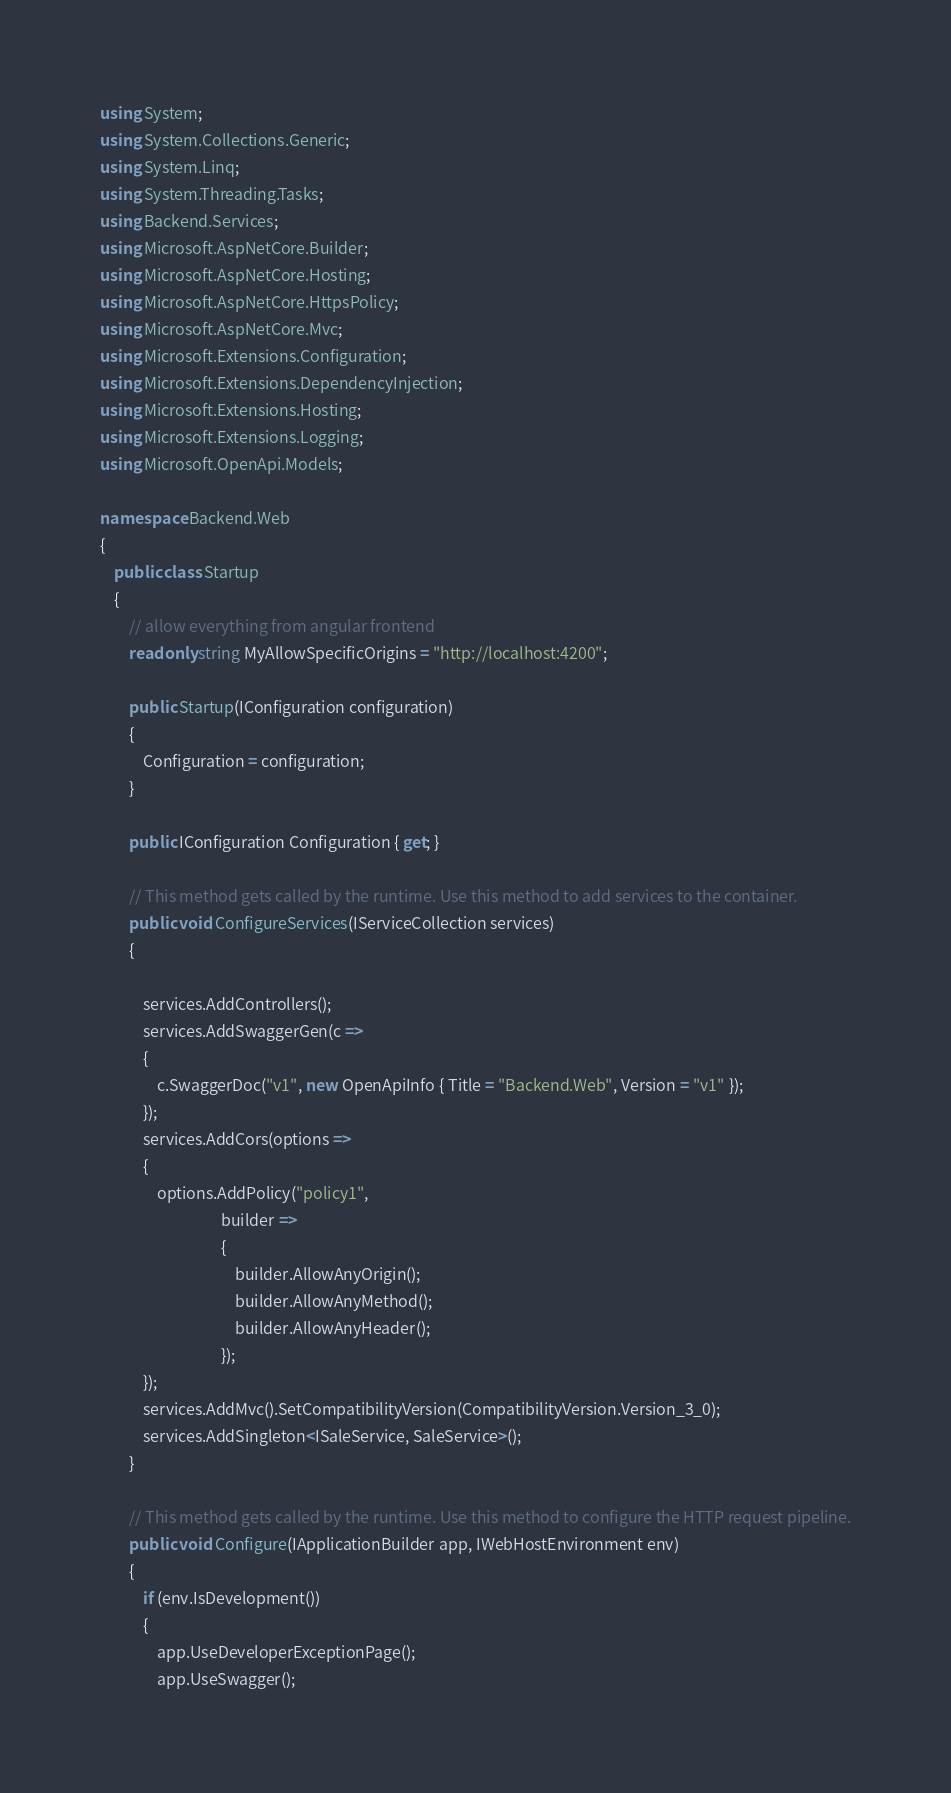<code> <loc_0><loc_0><loc_500><loc_500><_C#_>using System;
using System.Collections.Generic;
using System.Linq;
using System.Threading.Tasks;
using Backend.Services;
using Microsoft.AspNetCore.Builder;
using Microsoft.AspNetCore.Hosting;
using Microsoft.AspNetCore.HttpsPolicy;
using Microsoft.AspNetCore.Mvc;
using Microsoft.Extensions.Configuration;
using Microsoft.Extensions.DependencyInjection;
using Microsoft.Extensions.Hosting;
using Microsoft.Extensions.Logging;
using Microsoft.OpenApi.Models;

namespace Backend.Web
{
    public class Startup
    {
        // allow everything from angular frontend
        readonly string MyAllowSpecificOrigins = "http://localhost:4200";

        public Startup(IConfiguration configuration)
        {
            Configuration = configuration;
        }

        public IConfiguration Configuration { get; }

        // This method gets called by the runtime. Use this method to add services to the container.
        public void ConfigureServices(IServiceCollection services)
        {

            services.AddControllers();
            services.AddSwaggerGen(c =>
            {
                c.SwaggerDoc("v1", new OpenApiInfo { Title = "Backend.Web", Version = "v1" });
            });
            services.AddCors(options =>
            {
                options.AddPolicy("policy1",
                                  builder =>
                                  {
                                      builder.AllowAnyOrigin();
                                      builder.AllowAnyMethod();
                                      builder.AllowAnyHeader();
                                  });
            });
            services.AddMvc().SetCompatibilityVersion(CompatibilityVersion.Version_3_0);
            services.AddSingleton<ISaleService, SaleService>();
        }

        // This method gets called by the runtime. Use this method to configure the HTTP request pipeline.
        public void Configure(IApplicationBuilder app, IWebHostEnvironment env)
        {
            if (env.IsDevelopment())
            {
                app.UseDeveloperExceptionPage();
                app.UseSwagger();</code> 